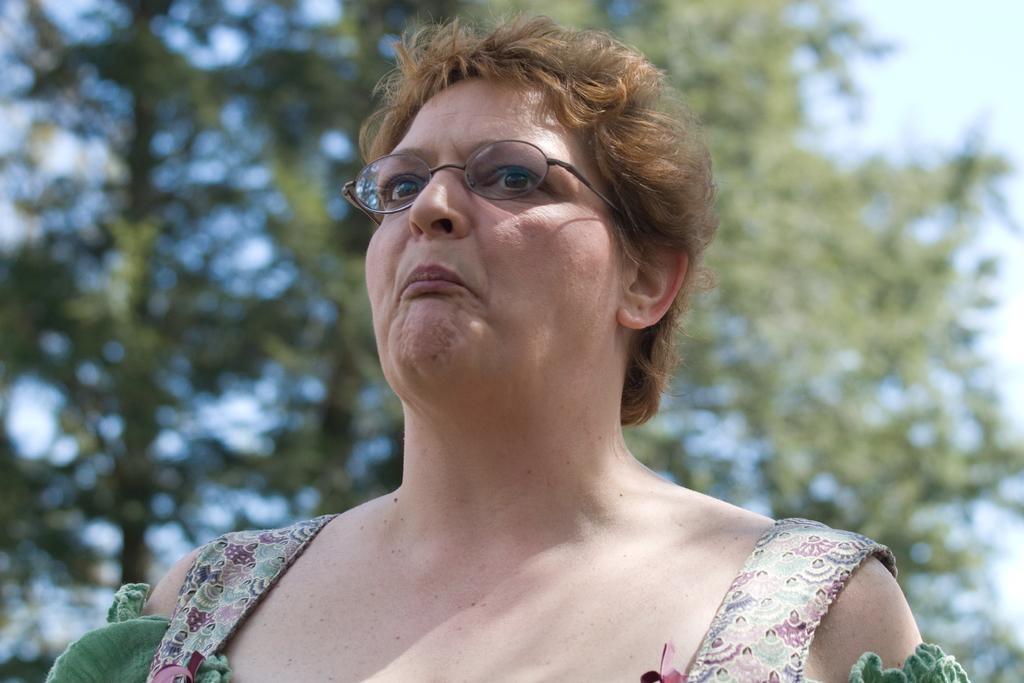Who is the main subject in the image? There is a lady in the center of the image. What is the lady wearing in the image? The lady is wearing glasses in the image. What can be seen in the background of the image? There are trees in the background of the image. What type of wool is being used to create the bridge in the image? There is no wool or bridge present in the image. 